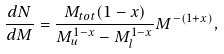Convert formula to latex. <formula><loc_0><loc_0><loc_500><loc_500>\frac { d N } { d M } = \frac { M _ { t o t } ( 1 - x ) } { M _ { u } ^ { 1 - x } - M _ { l } ^ { 1 - x } } M ^ { - ( 1 + x ) } ,</formula> 